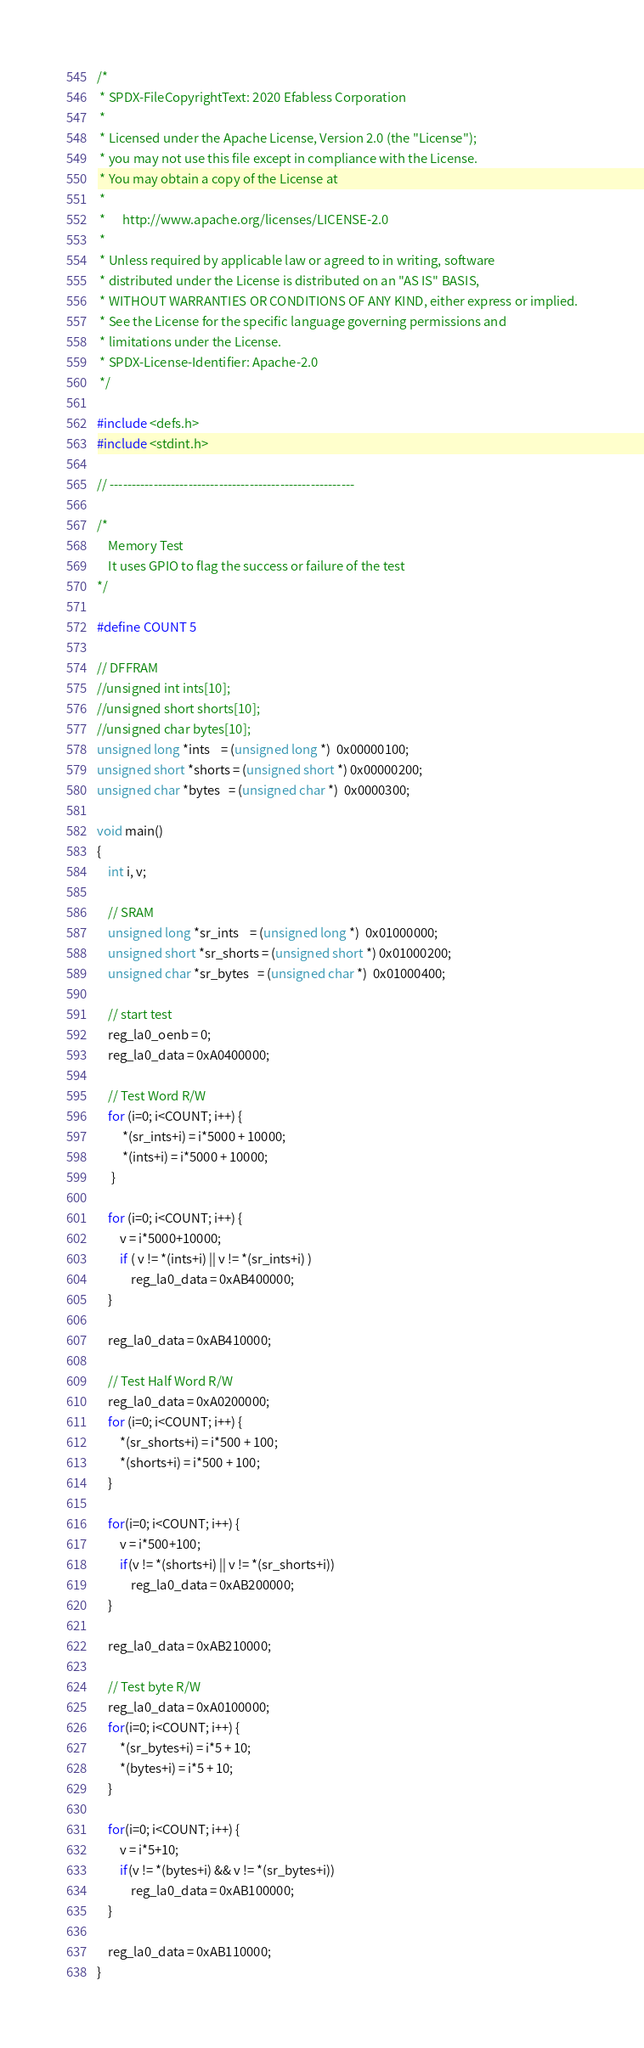<code> <loc_0><loc_0><loc_500><loc_500><_C_>/*
 * SPDX-FileCopyrightText: 2020 Efabless Corporation
 *
 * Licensed under the Apache License, Version 2.0 (the "License");
 * you may not use this file except in compliance with the License.
 * You may obtain a copy of the License at
 *
 *      http://www.apache.org/licenses/LICENSE-2.0
 *
 * Unless required by applicable law or agreed to in writing, software
 * distributed under the License is distributed on an "AS IS" BASIS,
 * WITHOUT WARRANTIES OR CONDITIONS OF ANY KIND, either express or implied.
 * See the License for the specific language governing permissions and
 * limitations under the License.
 * SPDX-License-Identifier: Apache-2.0
 */

#include <defs.h>
#include <stdint.h>

// --------------------------------------------------------

/*
	Memory Test
	It uses GPIO to flag the success or failure of the test
*/

#define COUNT 5

// DFFRAM
//unsigned int ints[10];
//unsigned short shorts[10];
//unsigned char bytes[10];
unsigned long *ints    = (unsigned long *)  0x00000100;
unsigned short *shorts = (unsigned short *) 0x00000200;
unsigned char *bytes   = (unsigned char *)  0x0000300;

void main()
{
    int i, v;

    // SRAM
    unsigned long *sr_ints    = (unsigned long *)  0x01000000;
    unsigned short *sr_shorts = (unsigned short *) 0x01000200;
    unsigned char *sr_bytes   = (unsigned char *)  0x01000400;

    // start test
    reg_la0_oenb = 0;
    reg_la0_data = 0xA0400000;

    // Test Word R/W
    for (i=0; i<COUNT; i++) {
	     *(sr_ints+i) = i*5000 + 10000;
	     *(ints+i) = i*5000 + 10000;
     }

    for (i=0; i<COUNT; i++) {
        v = i*5000+10000;
        if ( v != *(ints+i) || v != *(sr_ints+i) )
            reg_la0_data = 0xAB400000;
    }

    reg_la0_data = 0xAB410000;

    // Test Half Word R/W
    reg_la0_data = 0xA0200000;
    for (i=0; i<COUNT; i++) {
	    *(sr_shorts+i) = i*500 + 100;
	    *(shorts+i) = i*500 + 100;
    }

    for(i=0; i<COUNT; i++) {
        v = i*500+100;
        if(v != *(shorts+i) || v != *(sr_shorts+i))
            reg_la0_data = 0xAB200000;
    }

    reg_la0_data = 0xAB210000;

    // Test byte R/W
    reg_la0_data = 0xA0100000;
    for(i=0; i<COUNT; i++) {
        *(sr_bytes+i) = i*5 + 10;
        *(bytes+i) = i*5 + 10;
    }

    for(i=0; i<COUNT; i++) {
        v = i*5+10;
        if(v != *(bytes+i) && v != *(sr_bytes+i))
            reg_la0_data = 0xAB100000;
    }

    reg_la0_data = 0xAB110000;
}</code> 